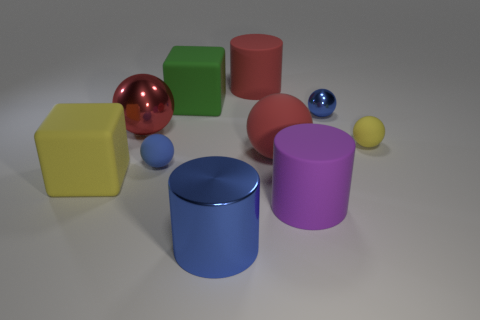If the objects were to symbolize a family, what roles might each play based on their sizes and colors? In an imaginative representation as a family, the large red cylinder could symbolize a parent due to its size and prominence. The smaller, vibrant-colored objects like the blue ball and the yellow ball might represent the children, bringing a sense of playfulness and diversity to the family dynamic. And what about the purple cylinder and the green cube? The purple cylinder, with its mid-range size, could be an older sibling or a teenage member of the family, while the green cube's solid and stable shape might represent the family's home or foundation. 